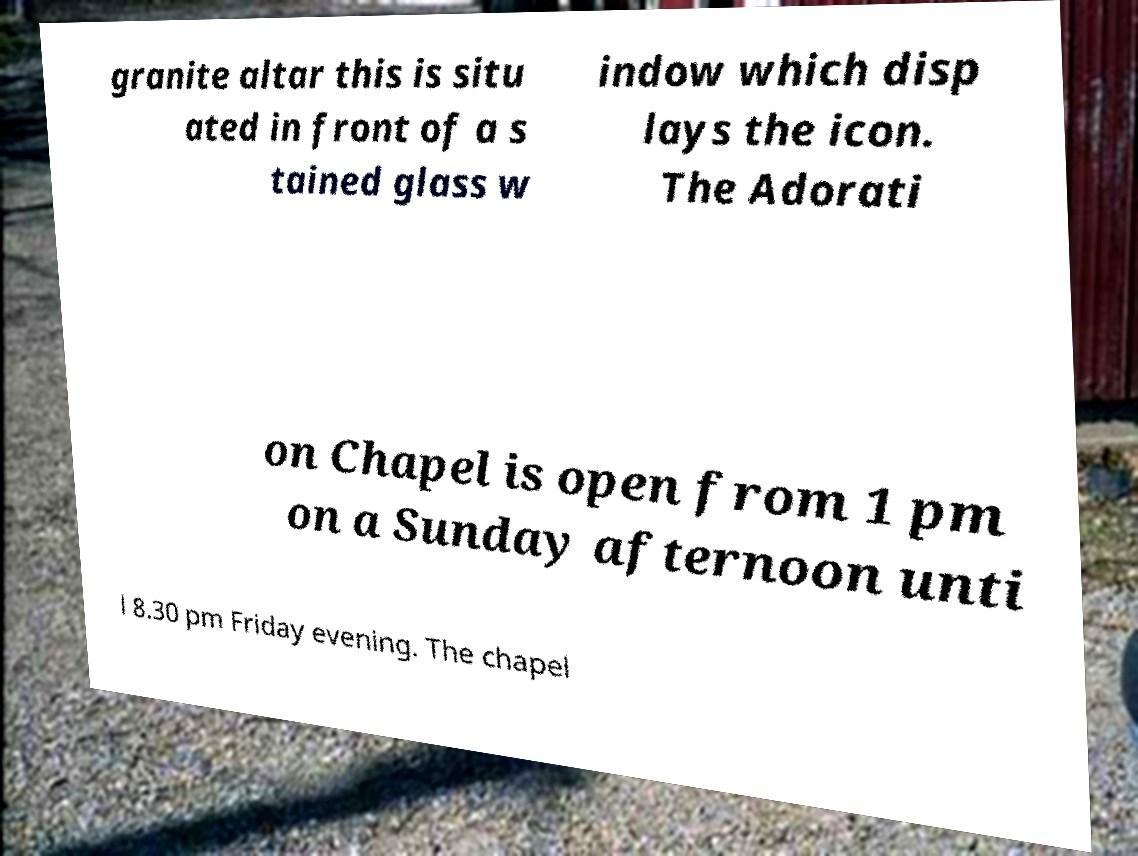I need the written content from this picture converted into text. Can you do that? granite altar this is situ ated in front of a s tained glass w indow which disp lays the icon. The Adorati on Chapel is open from 1 pm on a Sunday afternoon unti l 8.30 pm Friday evening. The chapel 